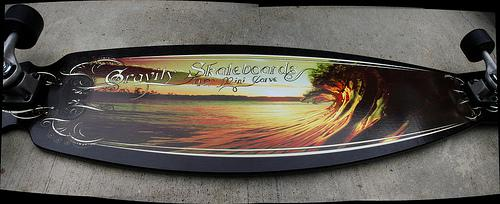Question: how many wheels can you see?
Choices:
A. One.
B. Three.
C. Two.
D. Four.
Answer with the letter. Answer: C Question: where is the painting?
Choices:
A. On the wall.
B. On the house.
C. On the building.
D. On the bottom of the skateboard.
Answer with the letter. Answer: D Question: where is the board?
Choices:
A. On the ground.
B. In the yard.
C. In the house.
D. In the shed.
Answer with the letter. Answer: A Question: what side is the board resting on?
Choices:
A. The bottom.
B. The right.
C. The top.
D. The left.
Answer with the letter. Answer: C Question: what is on the skateboard?
Choices:
A. Spirals.
B. Designs.
C. Waves.
D. Patterns.
Answer with the letter. Answer: C Question: what color are the wheels?
Choices:
A. Grey.
B. Brown.
C. White.
D. Black.
Answer with the letter. Answer: D 